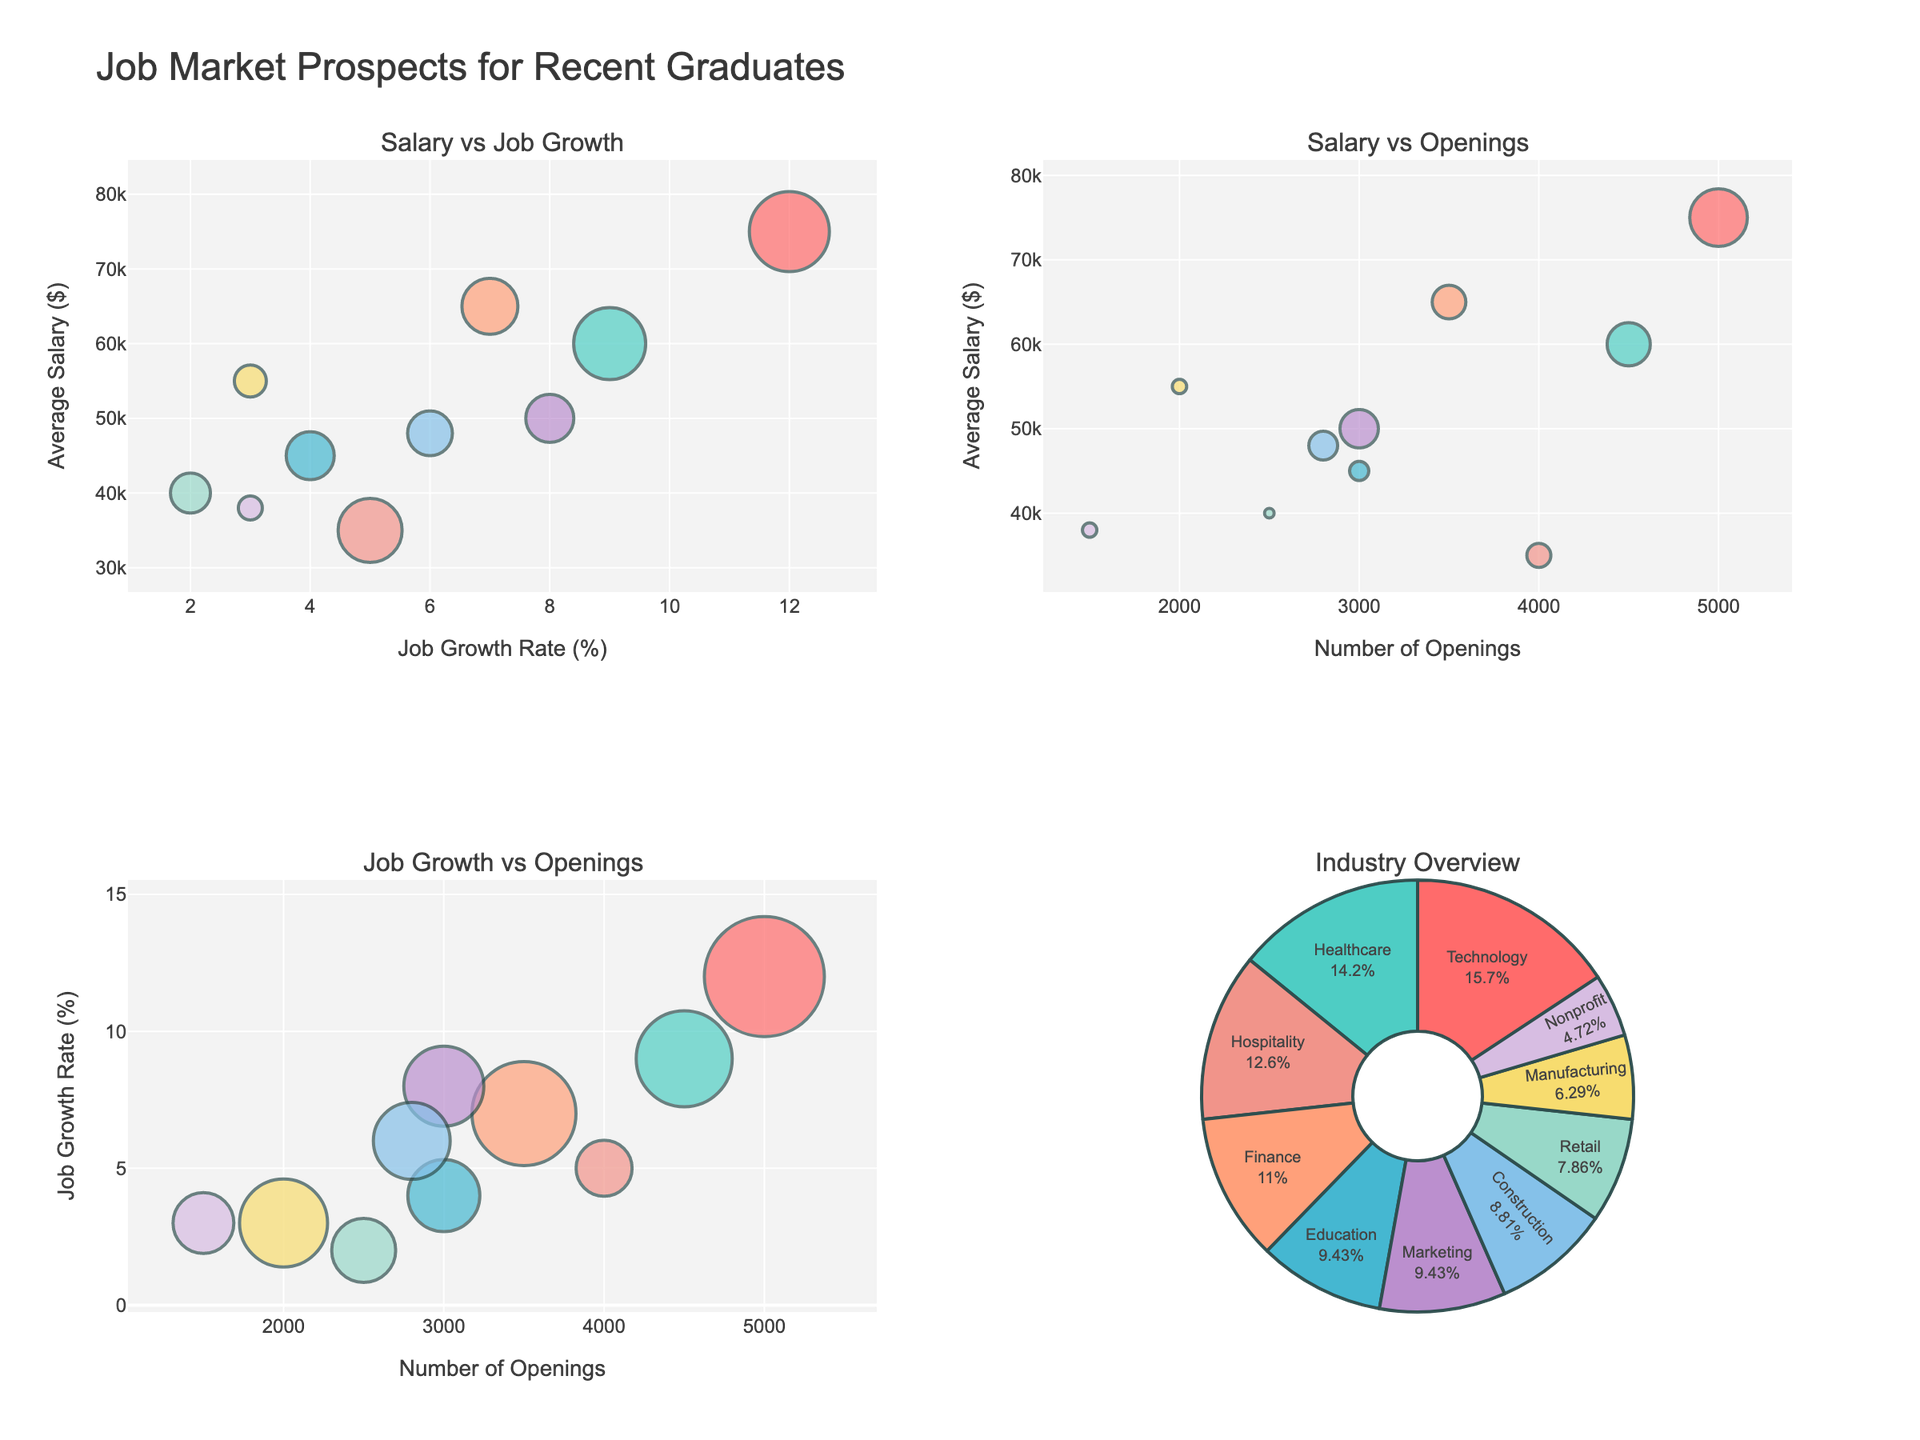How many different acting class types are displayed in the subplots? There are four subplots, each titled with a different acting class type: Scene Study, Improvisation, Method Acting, and Voice and Speech.
Answer: Four What does the y-axis represent in the subplots? Each subplot has the y-axis labeled as "Audition Success Rate (%)". This represents the percentage of auditions that were successful for the students.
Answer: Audition Success Rate (%) Which student has the highest audition success rate in the "Voice and Speech" class? Looking at the "Voice and Speech" subplot, the data points are marked with student names. James Wilson has the highest audition success rate with 40%.
Answer: James Wilson How many students attended more than 20 classes in the "Improvisation" class? Observing the Improvisation subplot, look for data points where the x-axis value (Acting Class Attendance) is greater than 20. In this case, there are no students represented attending more than 20 classes.
Answer: Zero Which class type shows the highest overall audition success rate based on the graphical data? Comparing the maximum y-axis values across all subplots, the "Scene Study" class shows the highest success rate with a student having a rate of 60%.
Answer: Scene Study Is there a positive correlation between acting class attendance and audition success rate for any specific class type? Positive correlation can be identified by observing if the points generally rise as you move from left to right. All four subplots show a general upward trend, indicating a positive correlation for "Scene Study", "Improvisation", "Method Acting", and "Voice and Speech" classes.
Answer: Yes, for all shown classes How does the "Scene Study" class compare to the "Improvisation" class in terms of average audition success rates? First, identify the success rates for each student in both classes, then calculate the average for each. "Scene Study" success rates are 15%, 60%. "Improvisation" success rates are 25%, 30%. The average for "Scene Study" is (15+60)/2 = 37.5%, and for "Improvisation" is (25+30)/2 = 27.5%.
Answer: Scene Study: 37.5%, Improvisation: 27.5% Which acting class type has the least variability in audition success rates among the students? Variability can be inferred from the spread of data points. A tighter clustering of points indicates less variability. Inspecting the subplots, "Voice and Speech" shows less variability compared to "Scene Study", "Improvisation", or "Method Acting".
Answer: Voice and Speech Do any students from the "Scene Study" class attend fewer than 15 classes yet have an audition success rate above 50%? Look at the "Scene Study" subplot for points below the 15 mark on the x-axis and above the 50 mark on the y-axis. There are no such points in this subplot.
Answer: No What is the general trend observed between class attendance and audition success rates? By examining all subplots, it’s visible that higher class attendance generally correlates with higher audition success rates, as most data points tend to rise in the y-direction as x values increase.
Answer: Positive correlation 